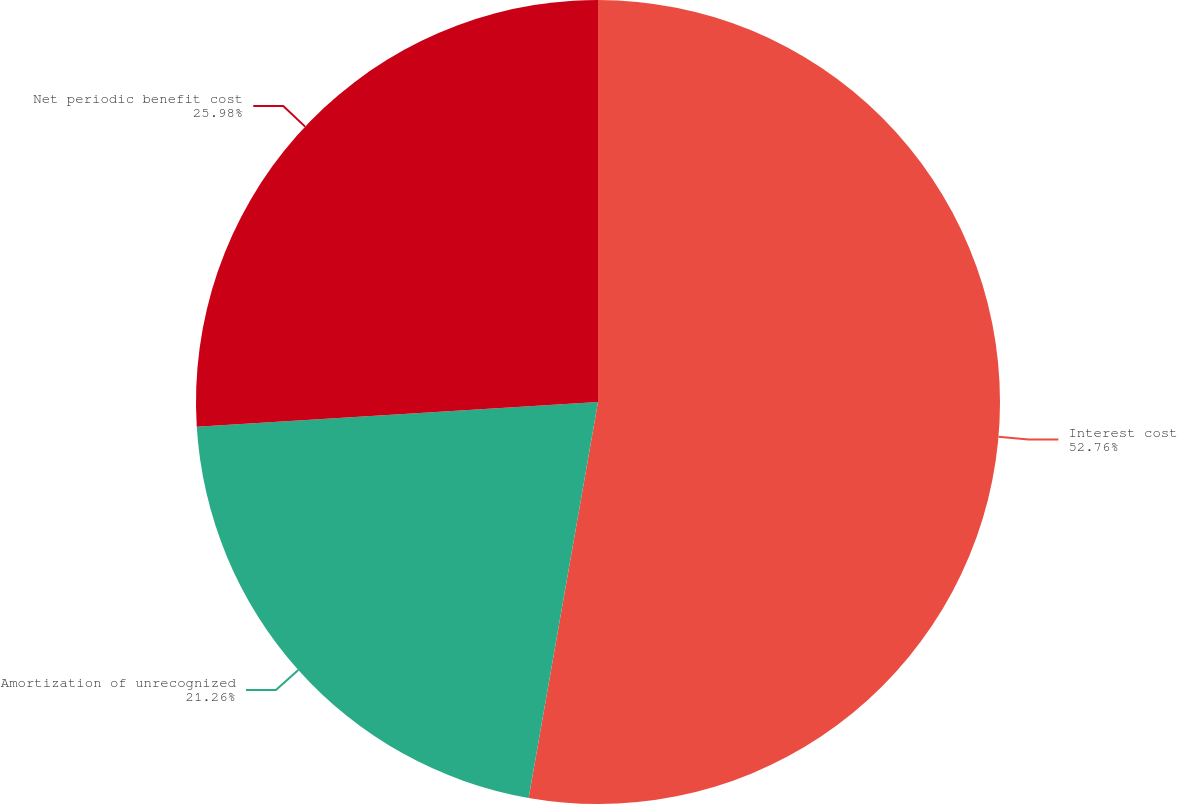<chart> <loc_0><loc_0><loc_500><loc_500><pie_chart><fcel>Interest cost<fcel>Amortization of unrecognized<fcel>Net periodic benefit cost<nl><fcel>52.76%<fcel>21.26%<fcel>25.98%<nl></chart> 